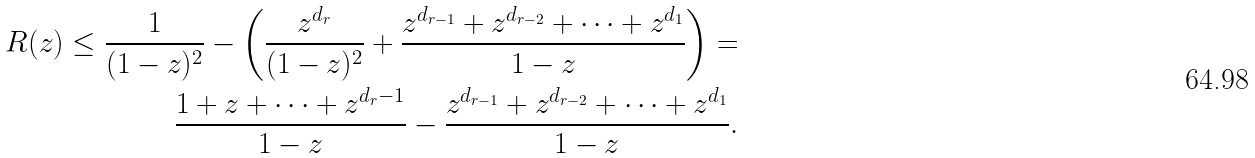Convert formula to latex. <formula><loc_0><loc_0><loc_500><loc_500>R ( z ) \leq \frac { 1 } { ( 1 - z ) ^ { 2 } } - \left ( \frac { z ^ { d _ { r } } } { ( 1 - z ) ^ { 2 } } + \frac { z ^ { d _ { r - 1 } } + z ^ { d _ { r - 2 } } + \cdots + z ^ { d _ { 1 } } } { 1 - z } \right ) = \\ \frac { 1 + z + \cdots + z ^ { d _ { r } - 1 } } { 1 - z } - \frac { z ^ { d _ { r - 1 } } + z ^ { d _ { r - 2 } } + \cdots + z ^ { d _ { 1 } } } { 1 - z } .</formula> 